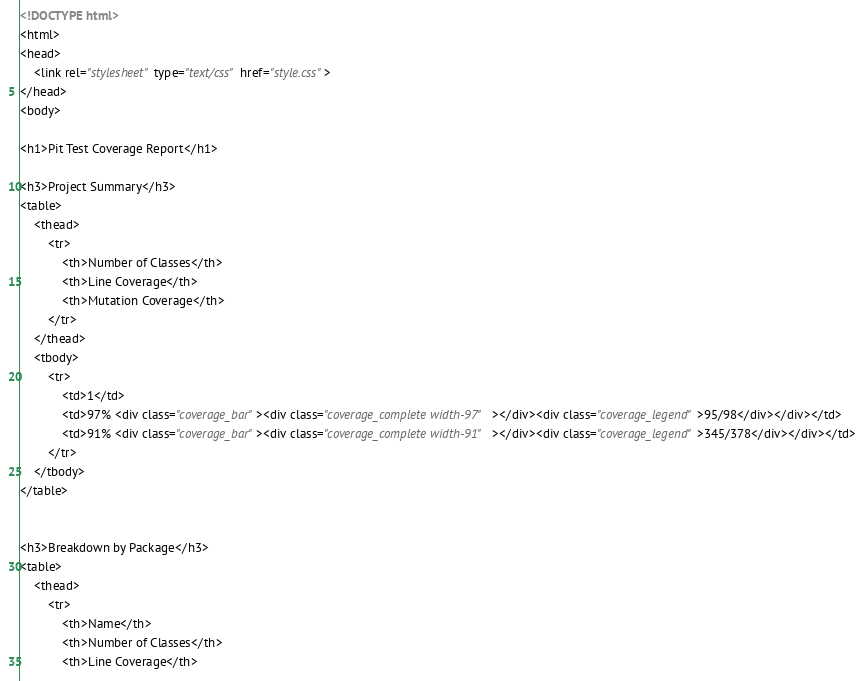Convert code to text. <code><loc_0><loc_0><loc_500><loc_500><_HTML_><!DOCTYPE html>
<html>
<head>
    <link rel="stylesheet" type="text/css" href="style.css">
</head>
<body>

<h1>Pit Test Coverage Report</h1>

<h3>Project Summary</h3>
<table>
    <thead>
        <tr>
            <th>Number of Classes</th>
            <th>Line Coverage</th>
            <th>Mutation Coverage</th>
        </tr>
    </thead>
    <tbody>
        <tr>
            <td>1</td>
            <td>97% <div class="coverage_bar"><div class="coverage_complete width-97"></div><div class="coverage_legend">95/98</div></div></td>
            <td>91% <div class="coverage_bar"><div class="coverage_complete width-91"></div><div class="coverage_legend">345/378</div></div></td>
        </tr>
    </tbody>
</table>


<h3>Breakdown by Package</h3>
<table>
    <thead>
        <tr>
            <th>Name</th>
            <th>Number of Classes</th>
            <th>Line Coverage</th></code> 